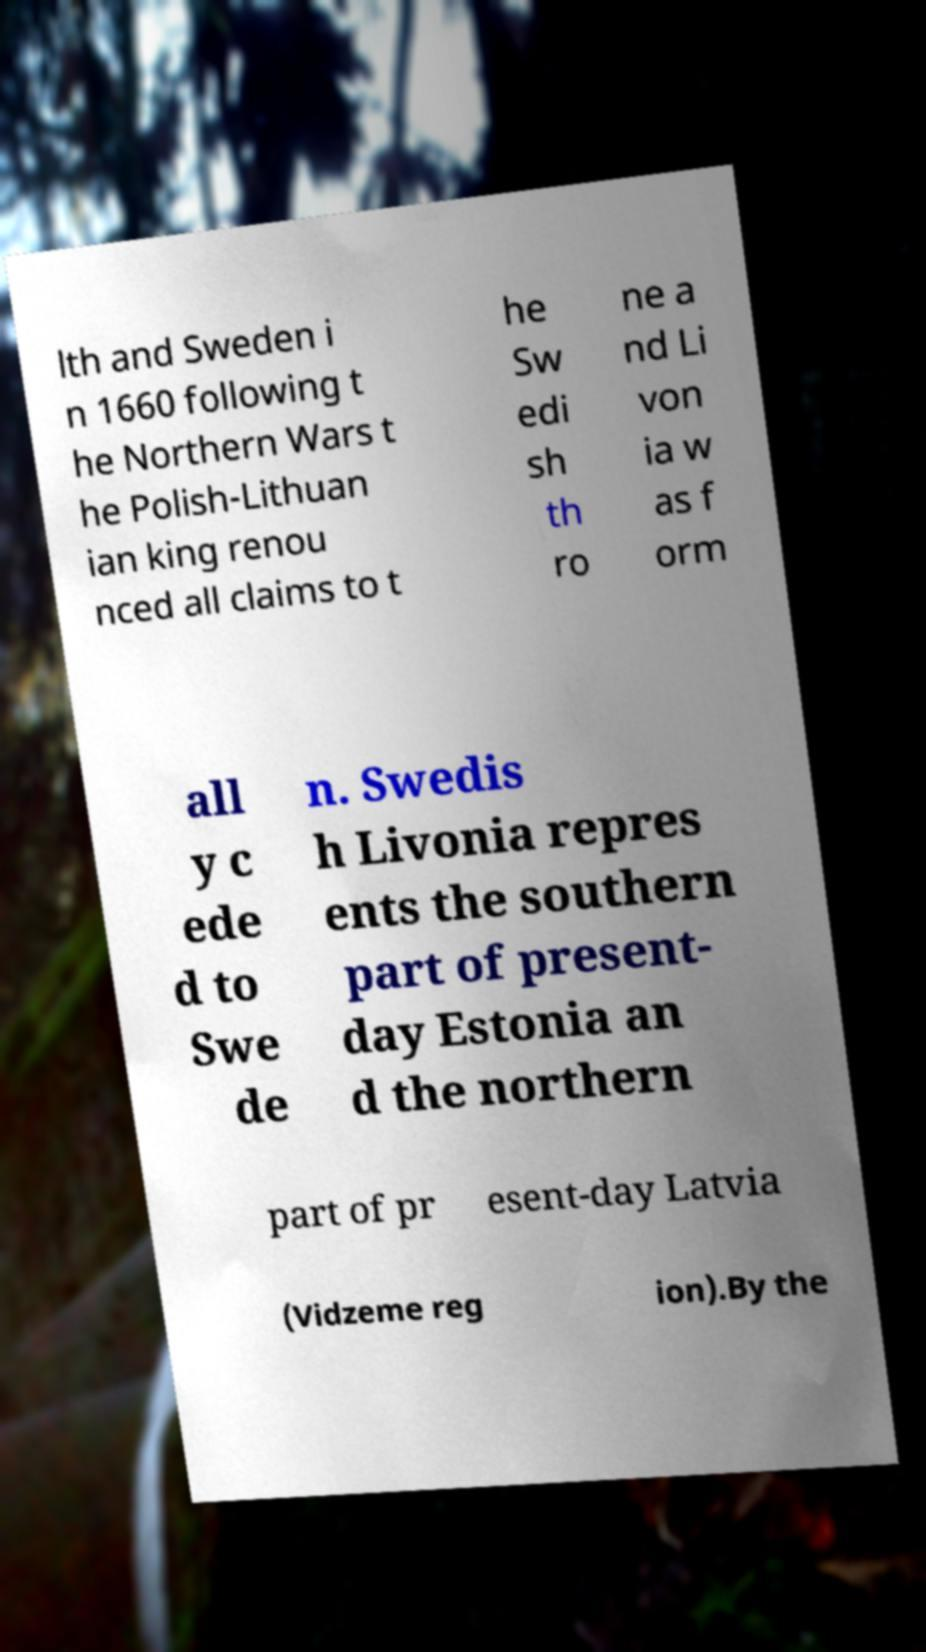Please identify and transcribe the text found in this image. lth and Sweden i n 1660 following t he Northern Wars t he Polish-Lithuan ian king renou nced all claims to t he Sw edi sh th ro ne a nd Li von ia w as f orm all y c ede d to Swe de n. Swedis h Livonia repres ents the southern part of present- day Estonia an d the northern part of pr esent-day Latvia (Vidzeme reg ion).By the 